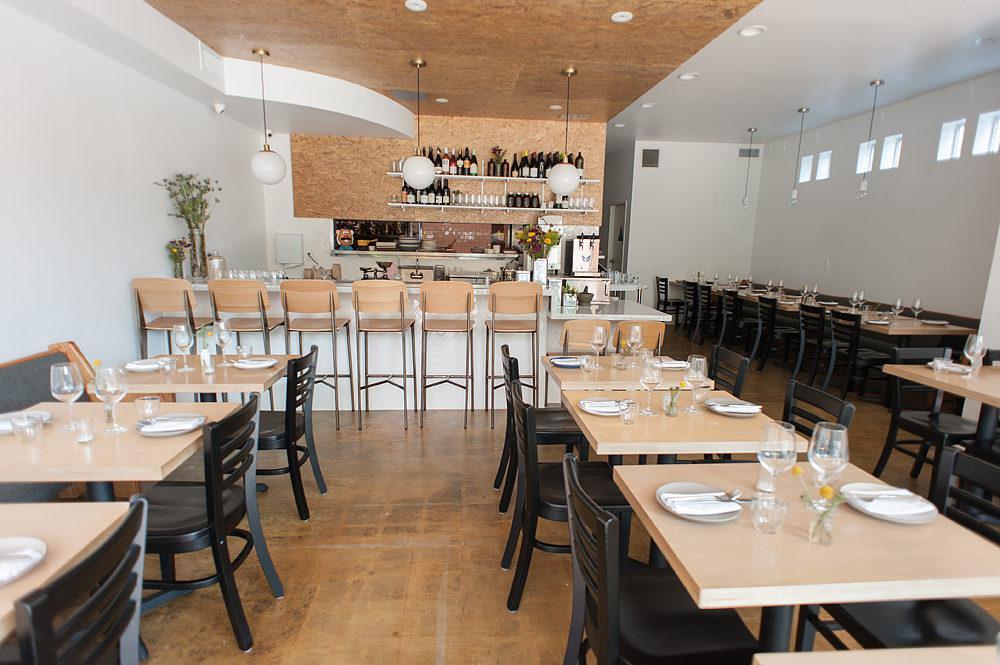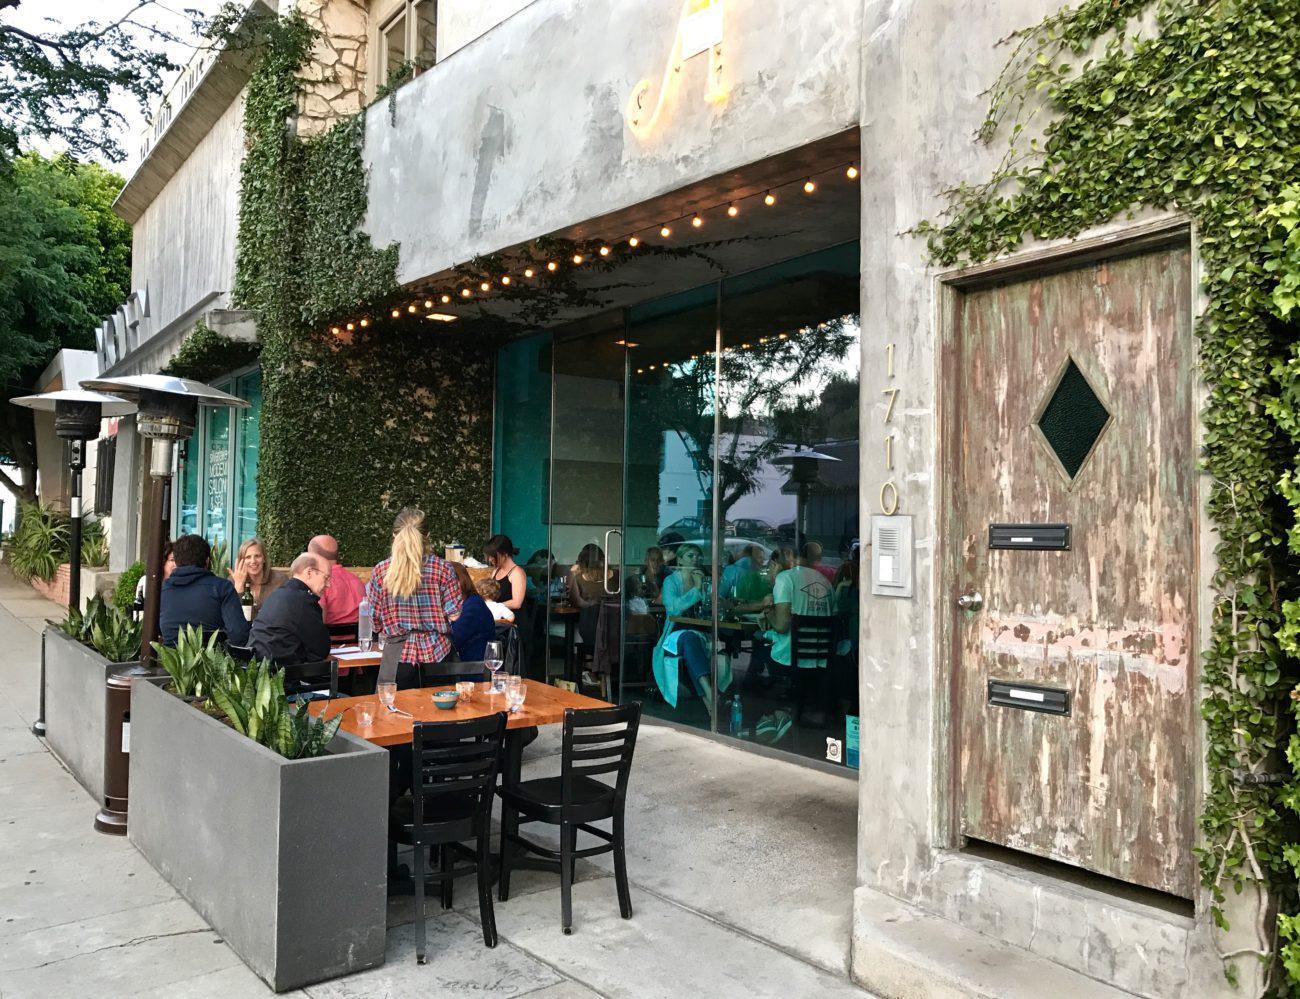The first image is the image on the left, the second image is the image on the right. For the images shown, is this caption "An exterior features a row of dark gray planters containing spiky green plants, in front of tables where customers are sitting, which are in front of a recessed window with a string of lights over it." true? Answer yes or no. Yes. The first image is the image on the left, the second image is the image on the right. Given the left and right images, does the statement "One image shows both bar- and table-seating inside a restaurant, while a second image shows outdoor table seating." hold true? Answer yes or no. Yes. 